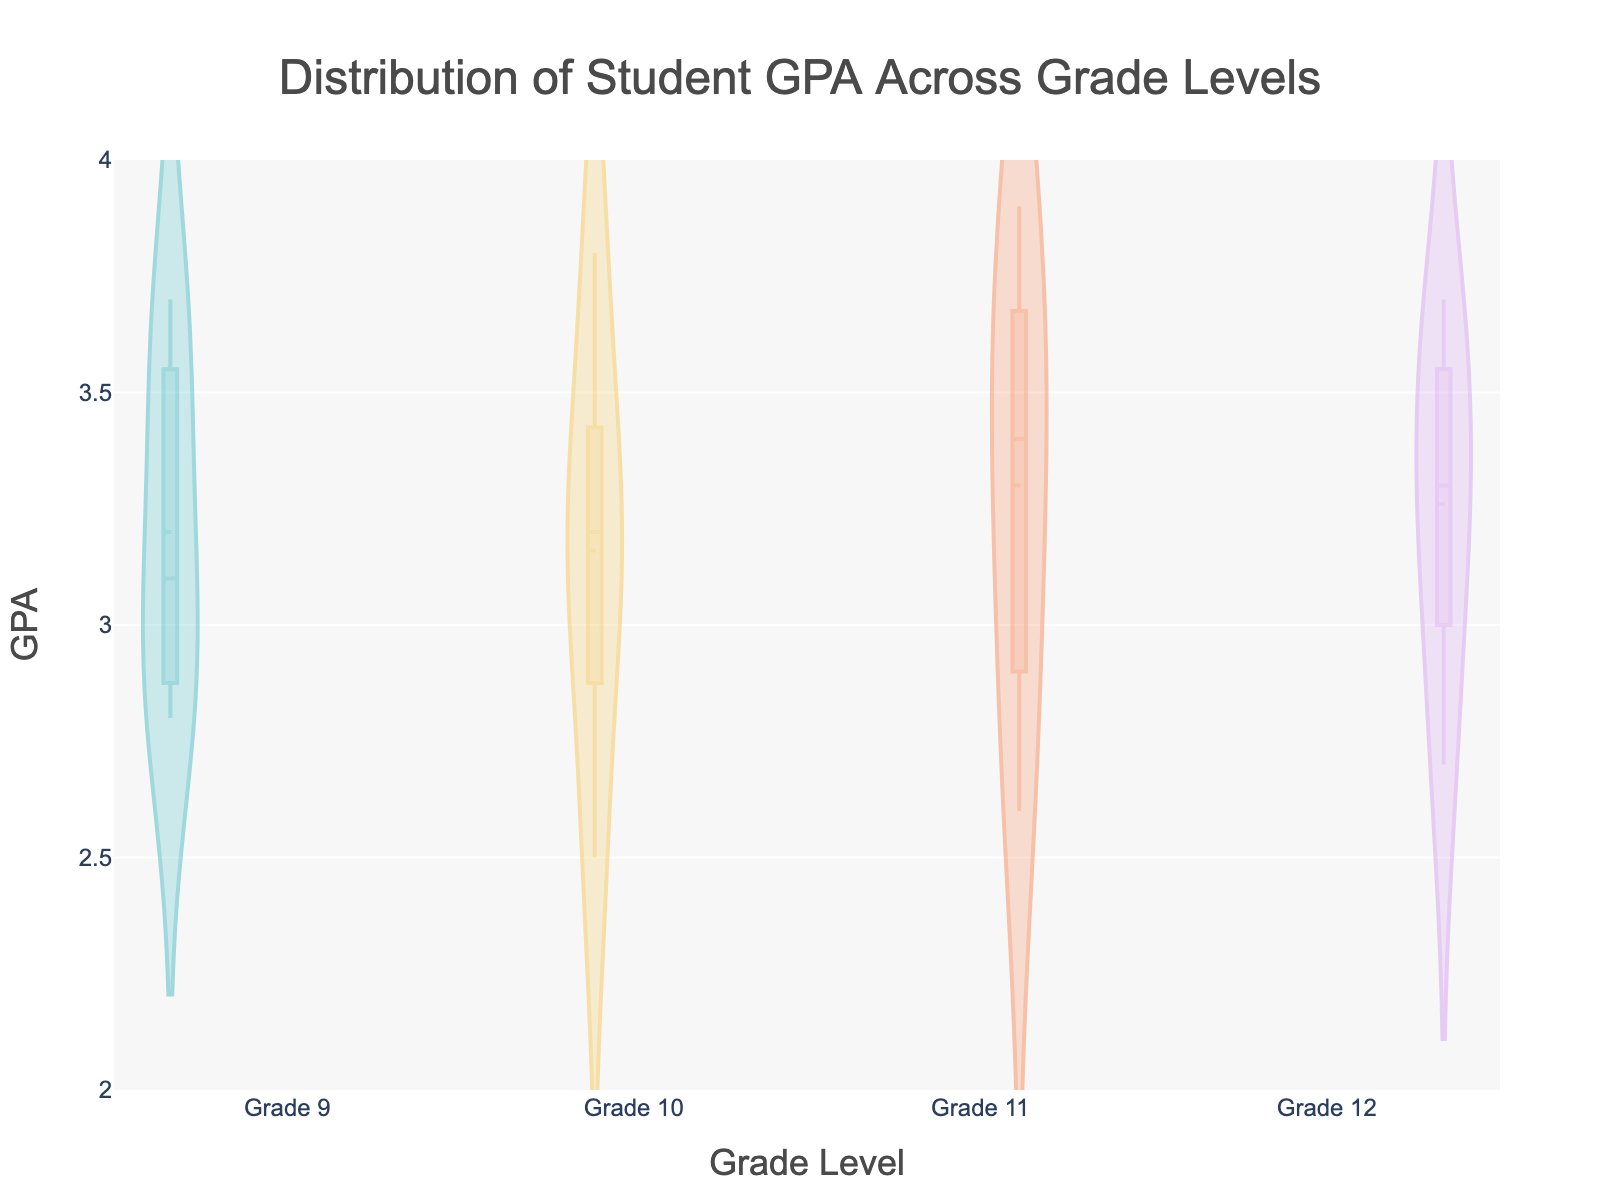What's the title of the figure? The title is displayed prominently at the top of the figure. It reads, 'Distribution of Student GPA Across Grade Levels'.
Answer: Distribution of Student GPA Across Grade Levels What is the GPAs range shown on the y-axis? The y-axis displays GPA values ranging from 2.0 to 4.0, which can be seen on the left side of the figure.
Answer: 2.0 to 4.0 Which grade level has the highest median GPA? The median GPA for each grade level can be identified by the middle line in each violin plot. By visually comparing the median lines, Grade 11 has the highest median GPA.
Answer: Grade 11 How do the GPA distributions for Grade 12 and Grade 9 compare in terms of spread? The spread of the distributions can be observed by the width and length of each violin plot. Grade 12 and Grade 9 distributions appear to have a similar spread, but Grade 12 has a slightly broader range.
Answer: Grade 12 has a slightly broader range What is the mean GPA for Grade 10? The mean GPA is indicated by a line within the box present in each violin plot. Observing the mean line in the Grade 10 plot, it aligns approximately at 3.16.
Answer: ~3.16 Which grade has the smallest number of outliers? Outliers are represented by points beyond the main body of the violin plot. Among all grades, Grade 10 shows the smallest number of outliers.
Answer: Grade 10 What is the interquartile range (IQR) for Grade 11? The IQR is the range between the first quartile (25th percentile) and the third quartile (75th percentile). For Grade 11, this appears to be approximately from 3.1 to 3.7 based on the box in the violin plot.
Answer: ~0.6 Which grade level has the most symmetric GPA distribution? Symmetry in a violin plot can be observed by comparing its halves. Grade 12 has the most symmetric distribution as both halves of the violin plot appear nearly identical.
Answer: Grade 12 How does the mean GPA for Grade 9 compare to Grade 12? The mean GPA for each grade can be determined by the mean line in each violin plot. By comparing these lines for Grade 9 and Grade 12, Grade 12 has a higher mean (around 3.26) compared to Grade 9 (around 3.2).
Answer: Grade 12 is higher What insight can you infer about the overall GPA trend from Grade 9 to Grade 12? Observing the median lines across grades indicates a general increase in GPAs from Grade 9 to Grade 11, with a slight decrease in Grade 12. This suggests improvement until Grade 11 before a minor dip in the final year.
Answer: Increase until Grade 11, then a slight decrease 